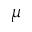Convert formula to latex. <formula><loc_0><loc_0><loc_500><loc_500>\mu</formula> 